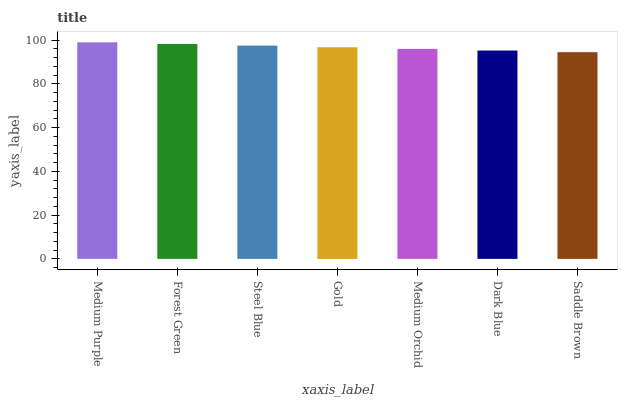Is Saddle Brown the minimum?
Answer yes or no. Yes. Is Medium Purple the maximum?
Answer yes or no. Yes. Is Forest Green the minimum?
Answer yes or no. No. Is Forest Green the maximum?
Answer yes or no. No. Is Medium Purple greater than Forest Green?
Answer yes or no. Yes. Is Forest Green less than Medium Purple?
Answer yes or no. Yes. Is Forest Green greater than Medium Purple?
Answer yes or no. No. Is Medium Purple less than Forest Green?
Answer yes or no. No. Is Gold the high median?
Answer yes or no. Yes. Is Gold the low median?
Answer yes or no. Yes. Is Medium Purple the high median?
Answer yes or no. No. Is Medium Orchid the low median?
Answer yes or no. No. 